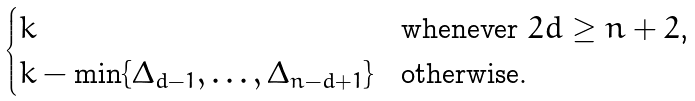Convert formula to latex. <formula><loc_0><loc_0><loc_500><loc_500>\begin{cases} k & \text {whenever $2d\geq n+2$,} \\ k - \min \{ \Delta _ { d - 1 } , \dots , \Delta _ { n - d + 1 } \} & \text {otherwise.} \end{cases}</formula> 